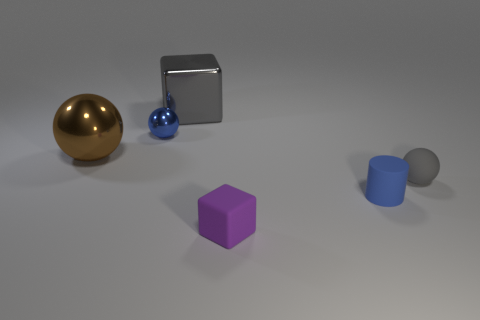Subtract all blue metal balls. How many balls are left? 2 Add 2 balls. How many objects exist? 8 Subtract all gray spheres. How many spheres are left? 2 Subtract 2 blocks. How many blocks are left? 0 Subtract all cylinders. How many objects are left? 5 Subtract 0 purple cylinders. How many objects are left? 6 Subtract all gray cylinders. Subtract all green spheres. How many cylinders are left? 1 Subtract all small gray matte things. Subtract all cyan blocks. How many objects are left? 5 Add 1 purple cubes. How many purple cubes are left? 2 Add 3 small purple rubber things. How many small purple rubber things exist? 4 